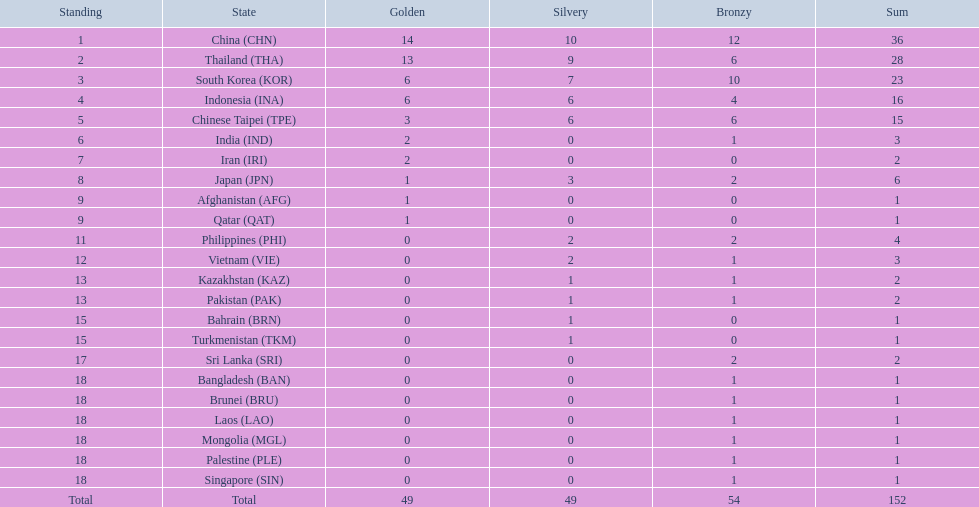Would you be able to parse every entry in this table? {'header': ['Standing', 'State', 'Golden', 'Silvery', 'Bronzy', 'Sum'], 'rows': [['1', 'China\xa0(CHN)', '14', '10', '12', '36'], ['2', 'Thailand\xa0(THA)', '13', '9', '6', '28'], ['3', 'South Korea\xa0(KOR)', '6', '7', '10', '23'], ['4', 'Indonesia\xa0(INA)', '6', '6', '4', '16'], ['5', 'Chinese Taipei\xa0(TPE)', '3', '6', '6', '15'], ['6', 'India\xa0(IND)', '2', '0', '1', '3'], ['7', 'Iran\xa0(IRI)', '2', '0', '0', '2'], ['8', 'Japan\xa0(JPN)', '1', '3', '2', '6'], ['9', 'Afghanistan\xa0(AFG)', '1', '0', '0', '1'], ['9', 'Qatar\xa0(QAT)', '1', '0', '0', '1'], ['11', 'Philippines\xa0(PHI)', '0', '2', '2', '4'], ['12', 'Vietnam\xa0(VIE)', '0', '2', '1', '3'], ['13', 'Kazakhstan\xa0(KAZ)', '0', '1', '1', '2'], ['13', 'Pakistan\xa0(PAK)', '0', '1', '1', '2'], ['15', 'Bahrain\xa0(BRN)', '0', '1', '0', '1'], ['15', 'Turkmenistan\xa0(TKM)', '0', '1', '0', '1'], ['17', 'Sri Lanka\xa0(SRI)', '0', '0', '2', '2'], ['18', 'Bangladesh\xa0(BAN)', '0', '0', '1', '1'], ['18', 'Brunei\xa0(BRU)', '0', '0', '1', '1'], ['18', 'Laos\xa0(LAO)', '0', '0', '1', '1'], ['18', 'Mongolia\xa0(MGL)', '0', '0', '1', '1'], ['18', 'Palestine\xa0(PLE)', '0', '0', '1', '1'], ['18', 'Singapore\xa0(SIN)', '0', '0', '1', '1'], ['Total', 'Total', '49', '49', '54', '152']]} How many nations received a medal in each gold, silver, and bronze? 6. 